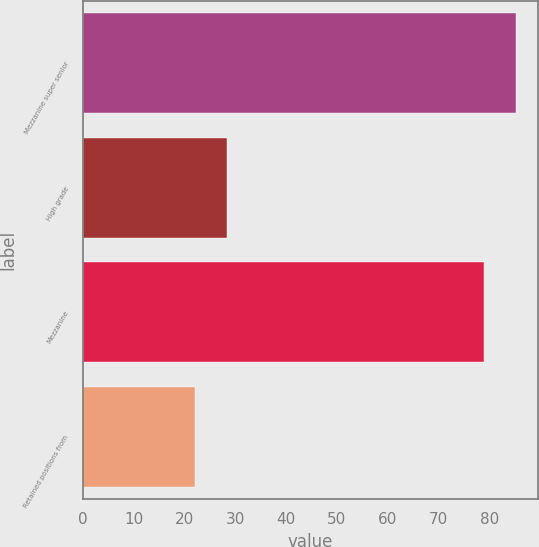Convert chart to OTSL. <chart><loc_0><loc_0><loc_500><loc_500><bar_chart><fcel>Mezzanine super senior<fcel>High grade<fcel>Mezzanine<fcel>Retained positions from<nl><fcel>85.3<fcel>28.3<fcel>79<fcel>22<nl></chart> 